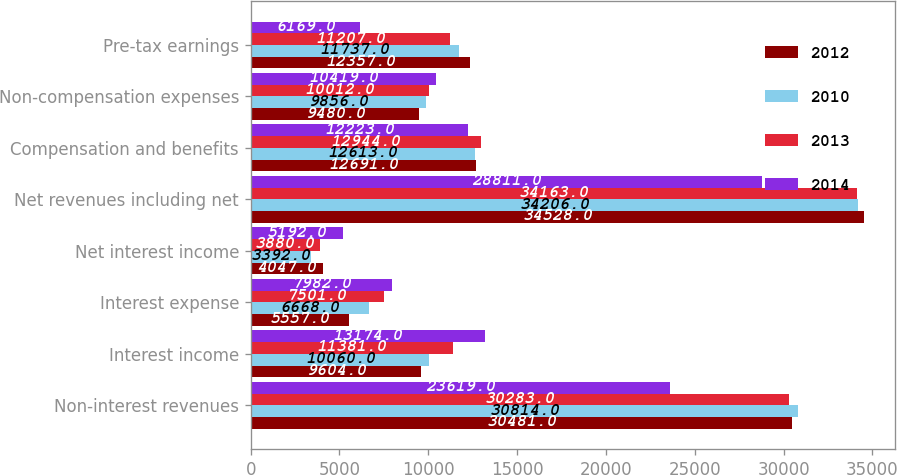<chart> <loc_0><loc_0><loc_500><loc_500><stacked_bar_chart><ecel><fcel>Non-interest revenues<fcel>Interest income<fcel>Interest expense<fcel>Net interest income<fcel>Net revenues including net<fcel>Compensation and benefits<fcel>Non-compensation expenses<fcel>Pre-tax earnings<nl><fcel>2012<fcel>30481<fcel>9604<fcel>5557<fcel>4047<fcel>34528<fcel>12691<fcel>9480<fcel>12357<nl><fcel>2010<fcel>30814<fcel>10060<fcel>6668<fcel>3392<fcel>34206<fcel>12613<fcel>9856<fcel>11737<nl><fcel>2013<fcel>30283<fcel>11381<fcel>7501<fcel>3880<fcel>34163<fcel>12944<fcel>10012<fcel>11207<nl><fcel>2014<fcel>23619<fcel>13174<fcel>7982<fcel>5192<fcel>28811<fcel>12223<fcel>10419<fcel>6169<nl></chart> 